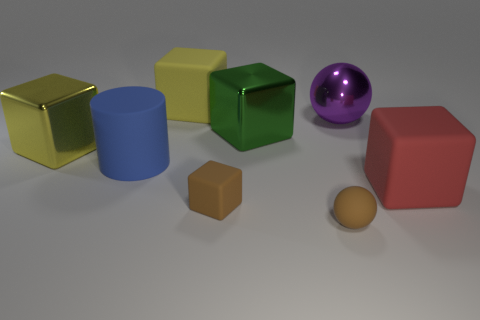Subtract 2 cubes. How many cubes are left? 3 Subtract all green cubes. How many cubes are left? 4 Subtract all big yellow matte blocks. How many blocks are left? 4 Subtract all blue blocks. Subtract all cyan spheres. How many blocks are left? 5 Add 2 cylinders. How many objects exist? 10 Subtract all cylinders. How many objects are left? 7 Subtract all large brown rubber blocks. Subtract all large yellow rubber blocks. How many objects are left? 7 Add 1 yellow things. How many yellow things are left? 3 Add 5 blocks. How many blocks exist? 10 Subtract 0 gray balls. How many objects are left? 8 